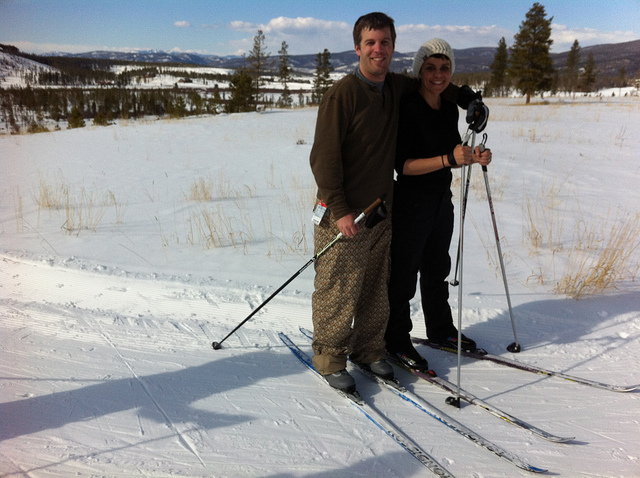<image>What is cast? I am not sure what cast is in this context. It could be shadow, sun, clouds, snow, or people. What is cast? I don't know what the cast is. It can be either a shadow, sun, clouds, snow or people. 